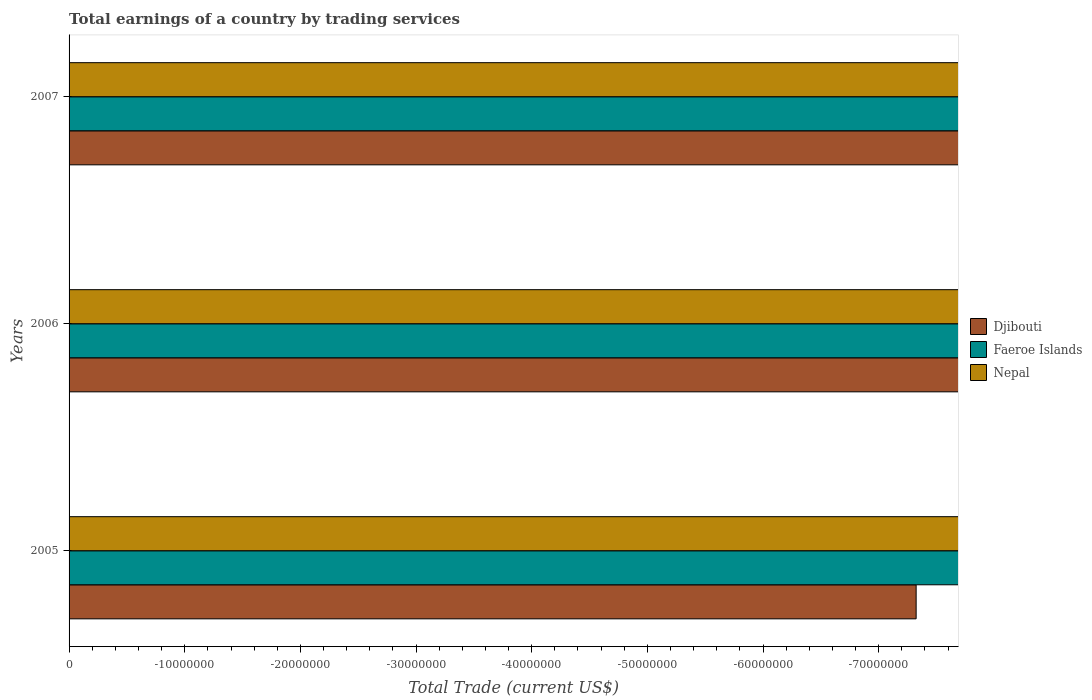Are the number of bars per tick equal to the number of legend labels?
Offer a very short reply. No. How many bars are there on the 2nd tick from the top?
Provide a short and direct response. 0. In how many cases, is the number of bars for a given year not equal to the number of legend labels?
Ensure brevity in your answer.  3. What is the total earnings in Djibouti in 2006?
Offer a very short reply. 0. What is the total total earnings in Nepal in the graph?
Your response must be concise. 0. What is the average total earnings in Faeroe Islands per year?
Make the answer very short. 0. In how many years, is the total earnings in Nepal greater than -24000000 US$?
Provide a short and direct response. 0. How many years are there in the graph?
Your response must be concise. 3. What is the difference between two consecutive major ticks on the X-axis?
Provide a succinct answer. 1.00e+07. Are the values on the major ticks of X-axis written in scientific E-notation?
Your response must be concise. No. Does the graph contain grids?
Ensure brevity in your answer.  No. Where does the legend appear in the graph?
Ensure brevity in your answer.  Center right. How many legend labels are there?
Keep it short and to the point. 3. What is the title of the graph?
Your answer should be compact. Total earnings of a country by trading services. What is the label or title of the X-axis?
Your response must be concise. Total Trade (current US$). What is the label or title of the Y-axis?
Ensure brevity in your answer.  Years. What is the Total Trade (current US$) of Faeroe Islands in 2006?
Ensure brevity in your answer.  0. What is the Total Trade (current US$) of Faeroe Islands in 2007?
Your response must be concise. 0. What is the total Total Trade (current US$) of Faeroe Islands in the graph?
Your answer should be compact. 0. What is the total Total Trade (current US$) of Nepal in the graph?
Offer a terse response. 0. What is the average Total Trade (current US$) of Djibouti per year?
Give a very brief answer. 0. 